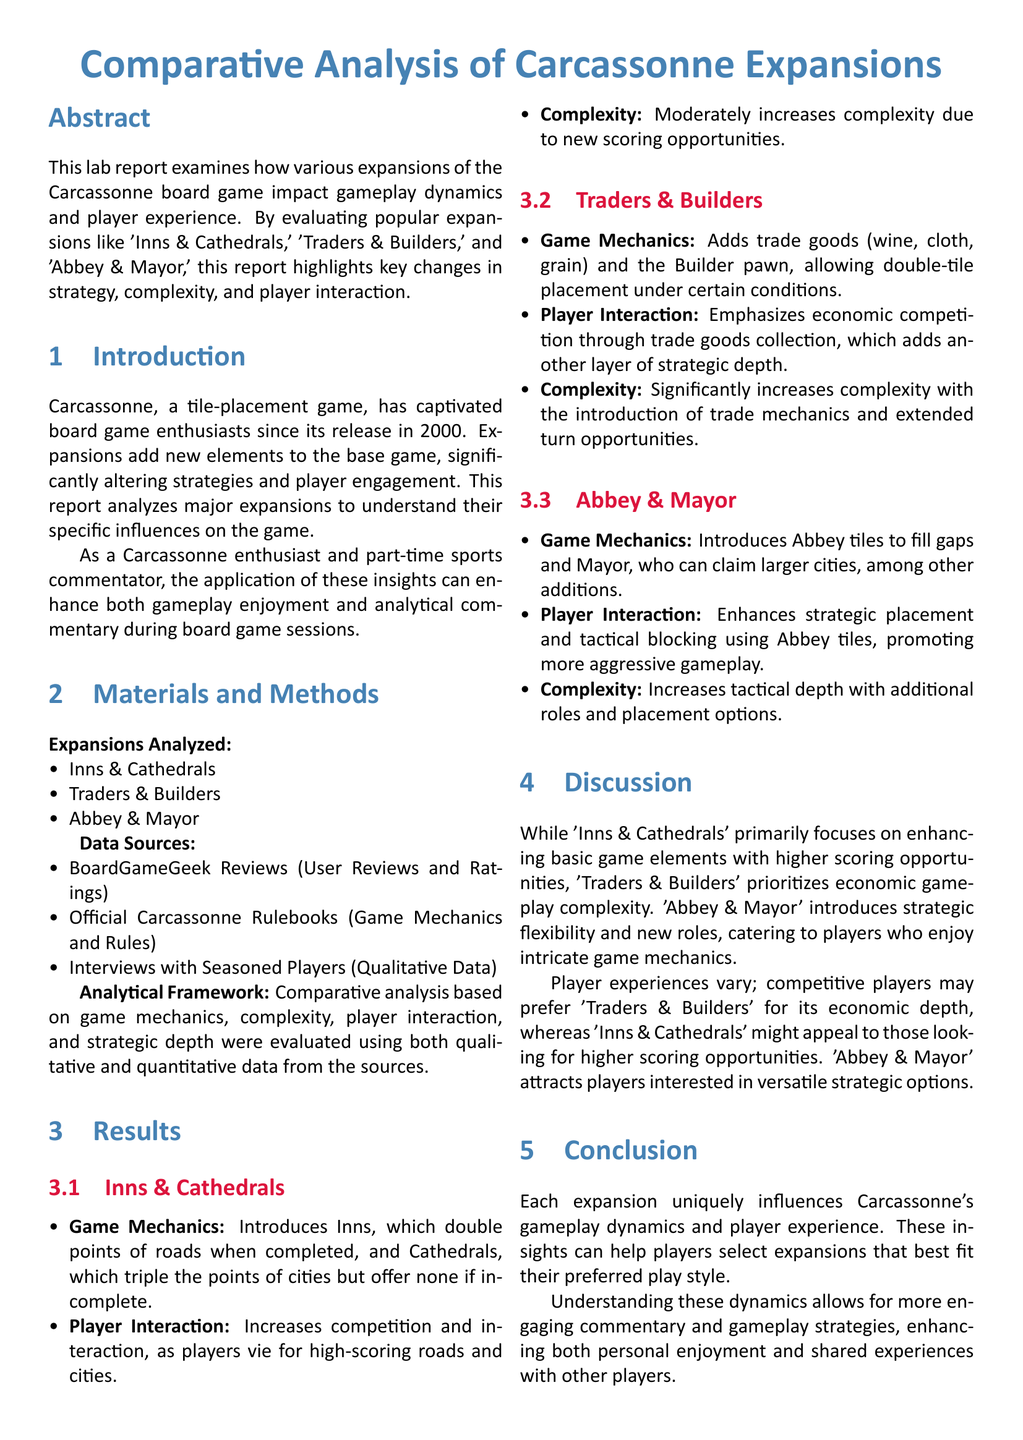What is the title of the lab report? The title of the lab report is stated at the beginning as a main heading.
Answer: Comparative Analysis of Carcassonne Expansions Which expansions are analyzed in the report? The report lists the expansions analyzed in the materials section.
Answer: Inns & Cathedrals, Traders & Builders, Abbey & Mayor What source provides qualitative data for the analysis? The report mentions several data sources, including interviews for qualitative input.
Answer: Interviews with Seasoned Players How does "Inns & Cathedrals" affect player interaction? The report details how player interaction is influenced by various mechanics in each expansion.
Answer: Increases competition and interaction What is the complexity increase of "Traders & Builders"? The document categorizes the complexity level of each expansion.
Answer: Significantly increases complexity Which expansion introduces trade goods? The details on each expansion highlight specific new game mechanics introduced.
Answer: Traders & Builders What strategic option does "Abbey & Mayor" introduce? The report outlines specific mechanics and strategic changes for each expansion.
Answer: Tactical blocking using Abbey tiles What is the focus of "Inns & Cathedrals" according to the discussion? The report summarizes the focus areas of each expansion in the discussion section.
Answer: Higher scoring opportunities Which player type may prefer "Traders & Builders"? The discussion section addresses preferences among different types of players based on game dynamics.
Answer: Competitive players 